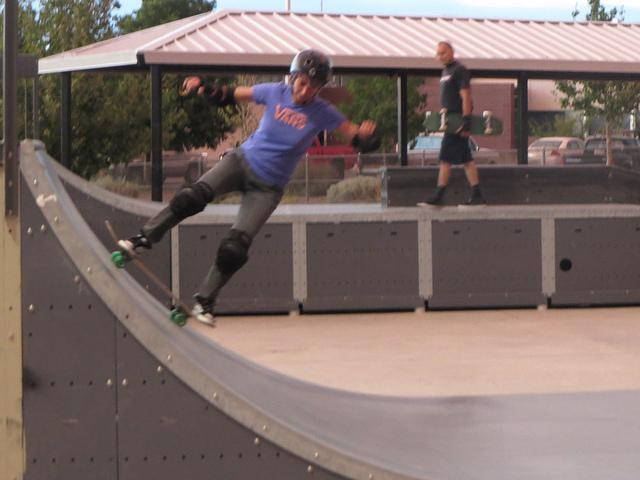On the front man what is most protected?

Choices:
A) knees
B) shins
C) chest
D) nose knees 